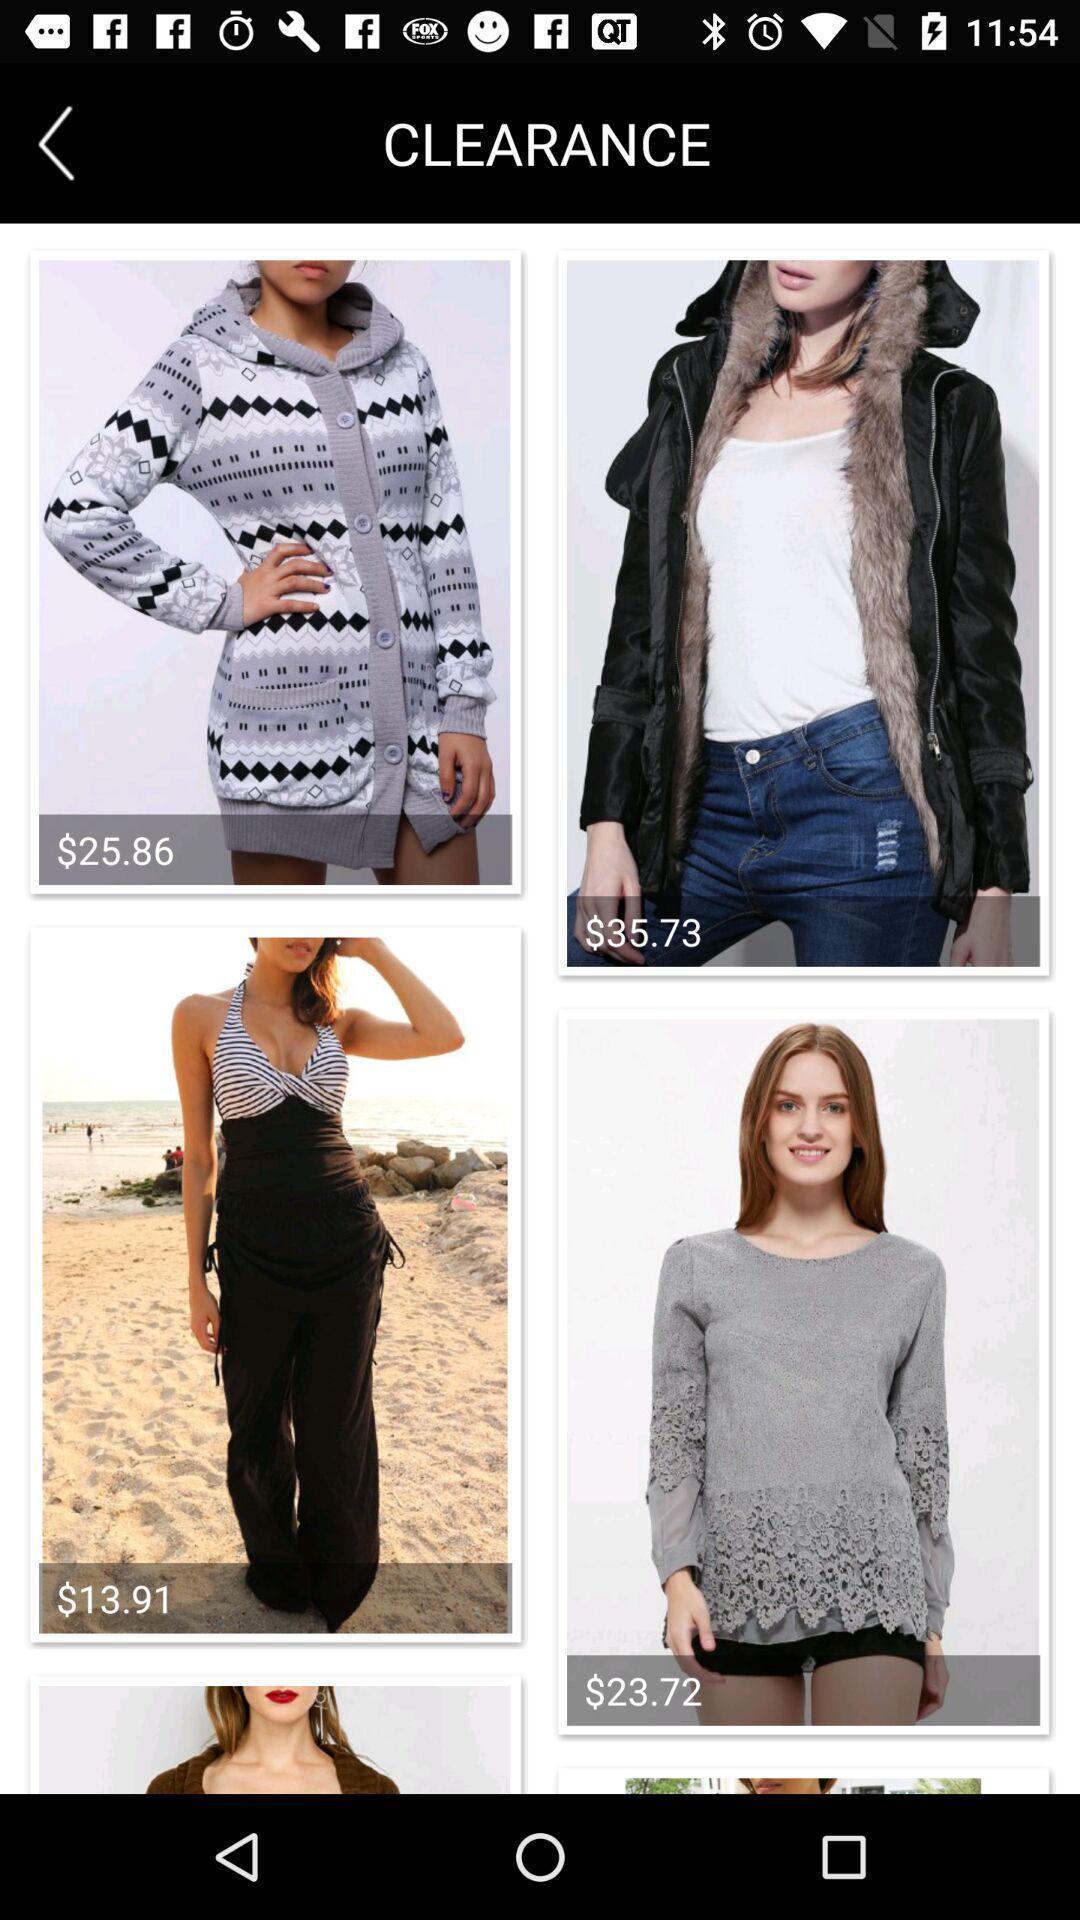Explain what's happening in this screen capture. Screen displaying the products in clearance page. 